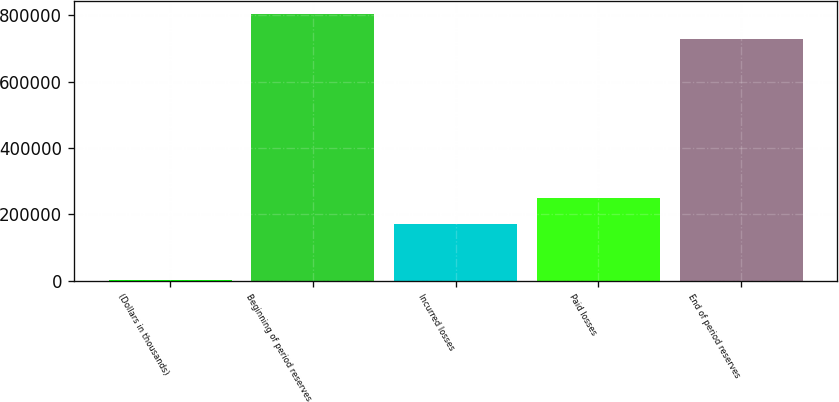<chart> <loc_0><loc_0><loc_500><loc_500><bar_chart><fcel>(Dollars in thousands)<fcel>Beginning of period reserves<fcel>Incurred losses<fcel>Paid losses<fcel>End of period reserves<nl><fcel>2004<fcel>804650<fcel>171729<fcel>248054<fcel>728325<nl></chart> 